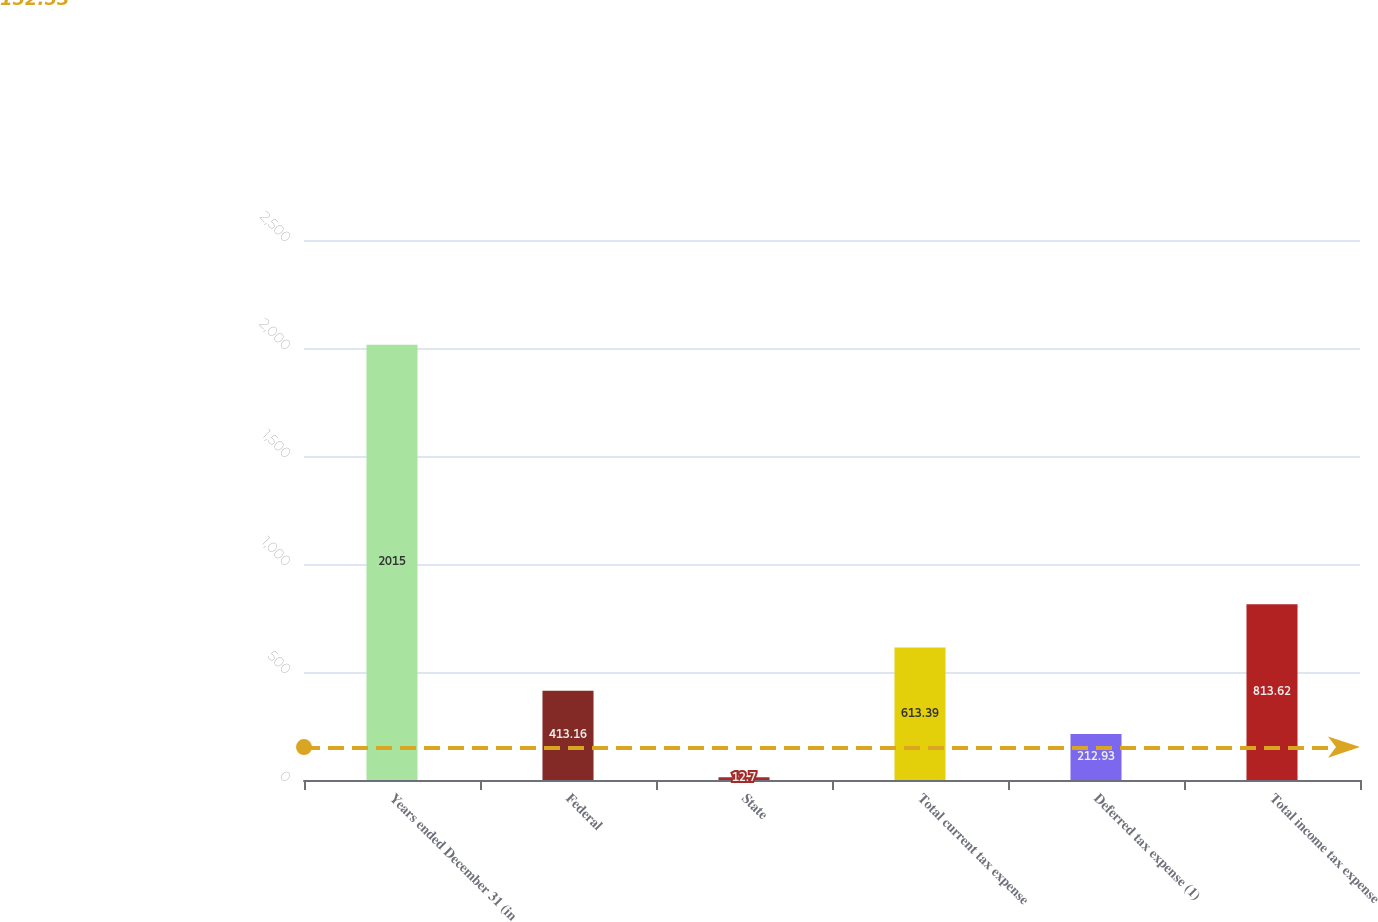Convert chart. <chart><loc_0><loc_0><loc_500><loc_500><bar_chart><fcel>Years ended December 31 (in<fcel>Federal<fcel>State<fcel>Total current tax expense<fcel>Deferred tax expense (1)<fcel>Total income tax expense<nl><fcel>2015<fcel>413.16<fcel>12.7<fcel>613.39<fcel>212.93<fcel>813.62<nl></chart> 